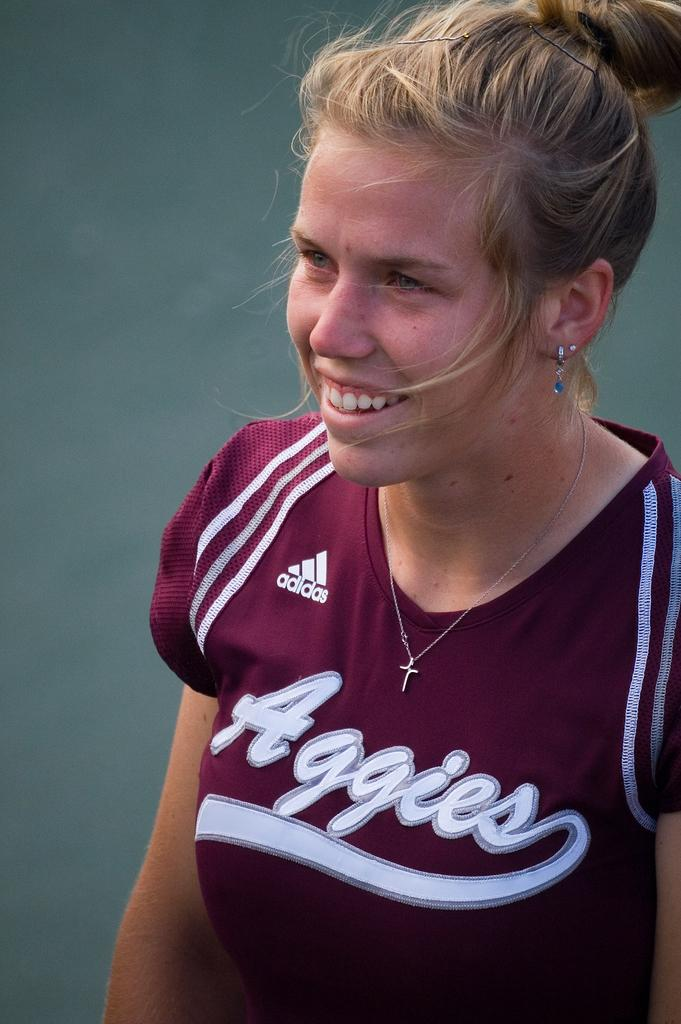<image>
Write a terse but informative summary of the picture. a woman wearing a maroon jersey with Aggies on it 